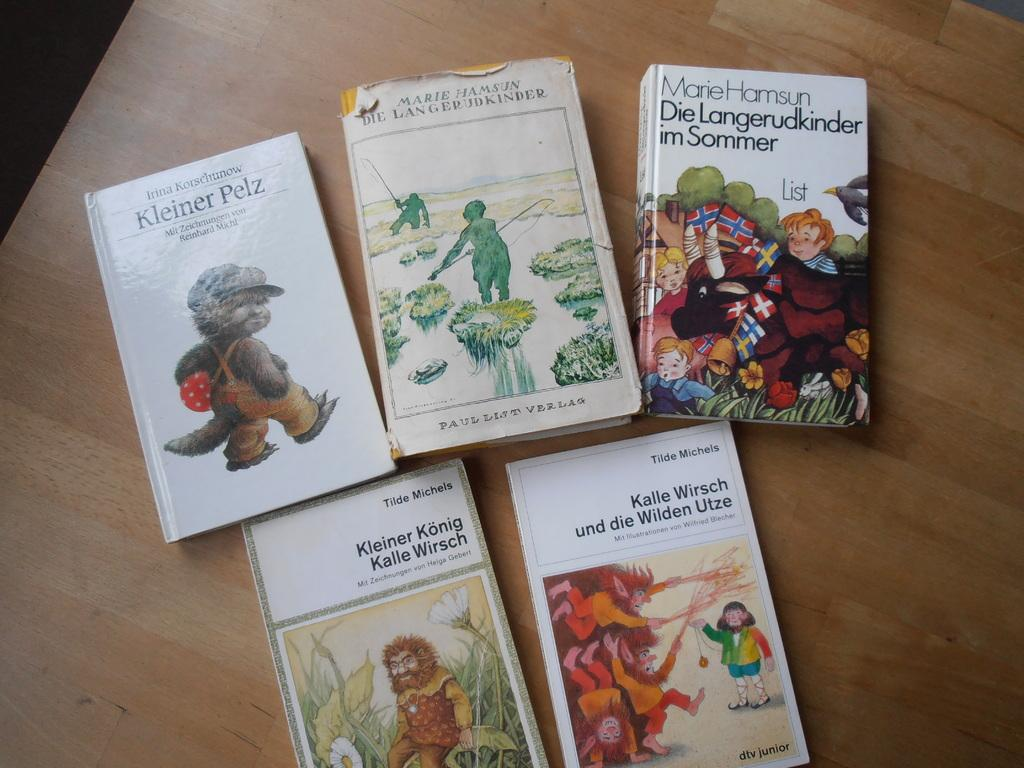<image>
Summarize the visual content of the image. A series of foreign children's books, with one titled Kleiner Pelz. 